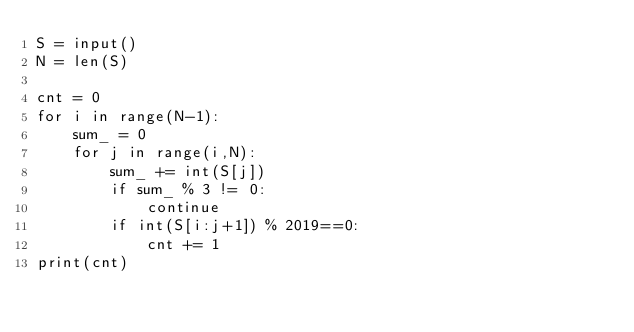<code> <loc_0><loc_0><loc_500><loc_500><_Python_>S = input()
N = len(S)

cnt = 0
for i in range(N-1):
    sum_ = 0
    for j in range(i,N):
        sum_ += int(S[j])
        if sum_ % 3 != 0:
            continue
        if int(S[i:j+1]) % 2019==0:
            cnt += 1
print(cnt)</code> 